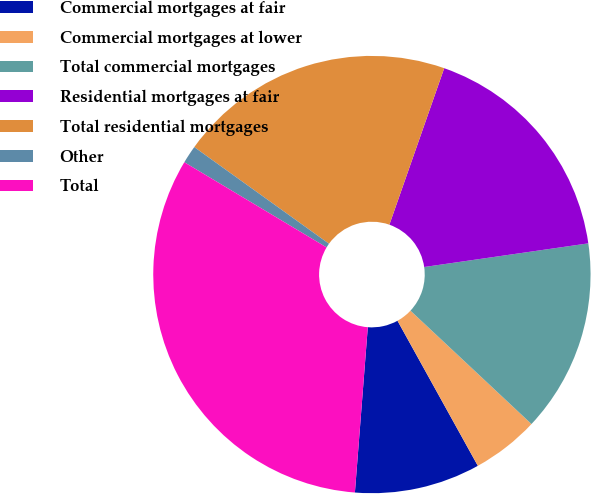<chart> <loc_0><loc_0><loc_500><loc_500><pie_chart><fcel>Commercial mortgages at fair<fcel>Commercial mortgages at lower<fcel>Total commercial mortgages<fcel>Residential mortgages at fair<fcel>Total residential mortgages<fcel>Other<fcel>Total<nl><fcel>9.29%<fcel>4.97%<fcel>14.26%<fcel>17.36%<fcel>20.46%<fcel>1.32%<fcel>32.35%<nl></chart> 